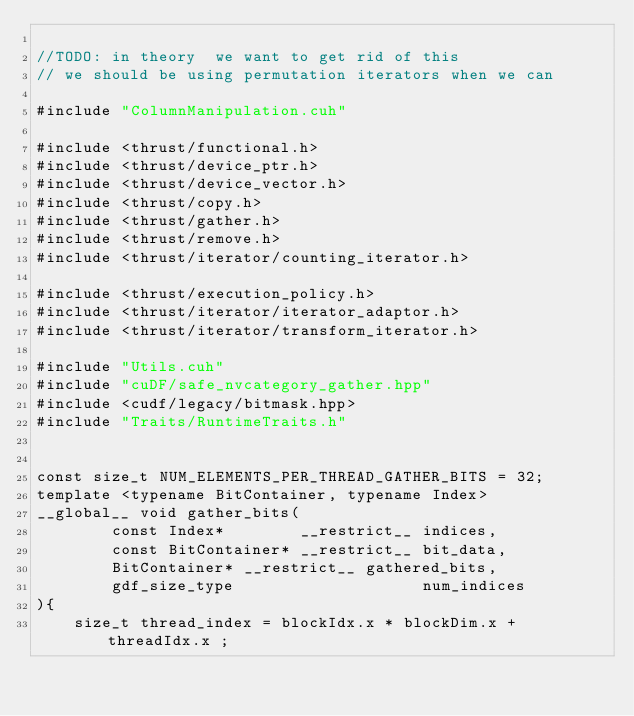<code> <loc_0><loc_0><loc_500><loc_500><_Cuda_>
//TODO: in theory  we want to get rid of this
// we should be using permutation iterators when we can

#include "ColumnManipulation.cuh"

#include <thrust/functional.h>
#include <thrust/device_ptr.h>
#include <thrust/device_vector.h>
#include <thrust/copy.h>
#include <thrust/gather.h>
#include <thrust/remove.h>
#include <thrust/iterator/counting_iterator.h>

#include <thrust/execution_policy.h>
#include <thrust/iterator/iterator_adaptor.h>
#include <thrust/iterator/transform_iterator.h>

#include "Utils.cuh"
#include "cuDF/safe_nvcategory_gather.hpp"
#include <cudf/legacy/bitmask.hpp>
#include "Traits/RuntimeTraits.h"


const size_t NUM_ELEMENTS_PER_THREAD_GATHER_BITS = 32;
template <typename BitContainer, typename Index>
__global__ void gather_bits(
		const Index*        __restrict__ indices,
		const BitContainer* __restrict__ bit_data,
		BitContainer* __restrict__ gathered_bits,
		gdf_size_type                    num_indices
){
	size_t thread_index = blockIdx.x * blockDim.x + threadIdx.x ;</code> 